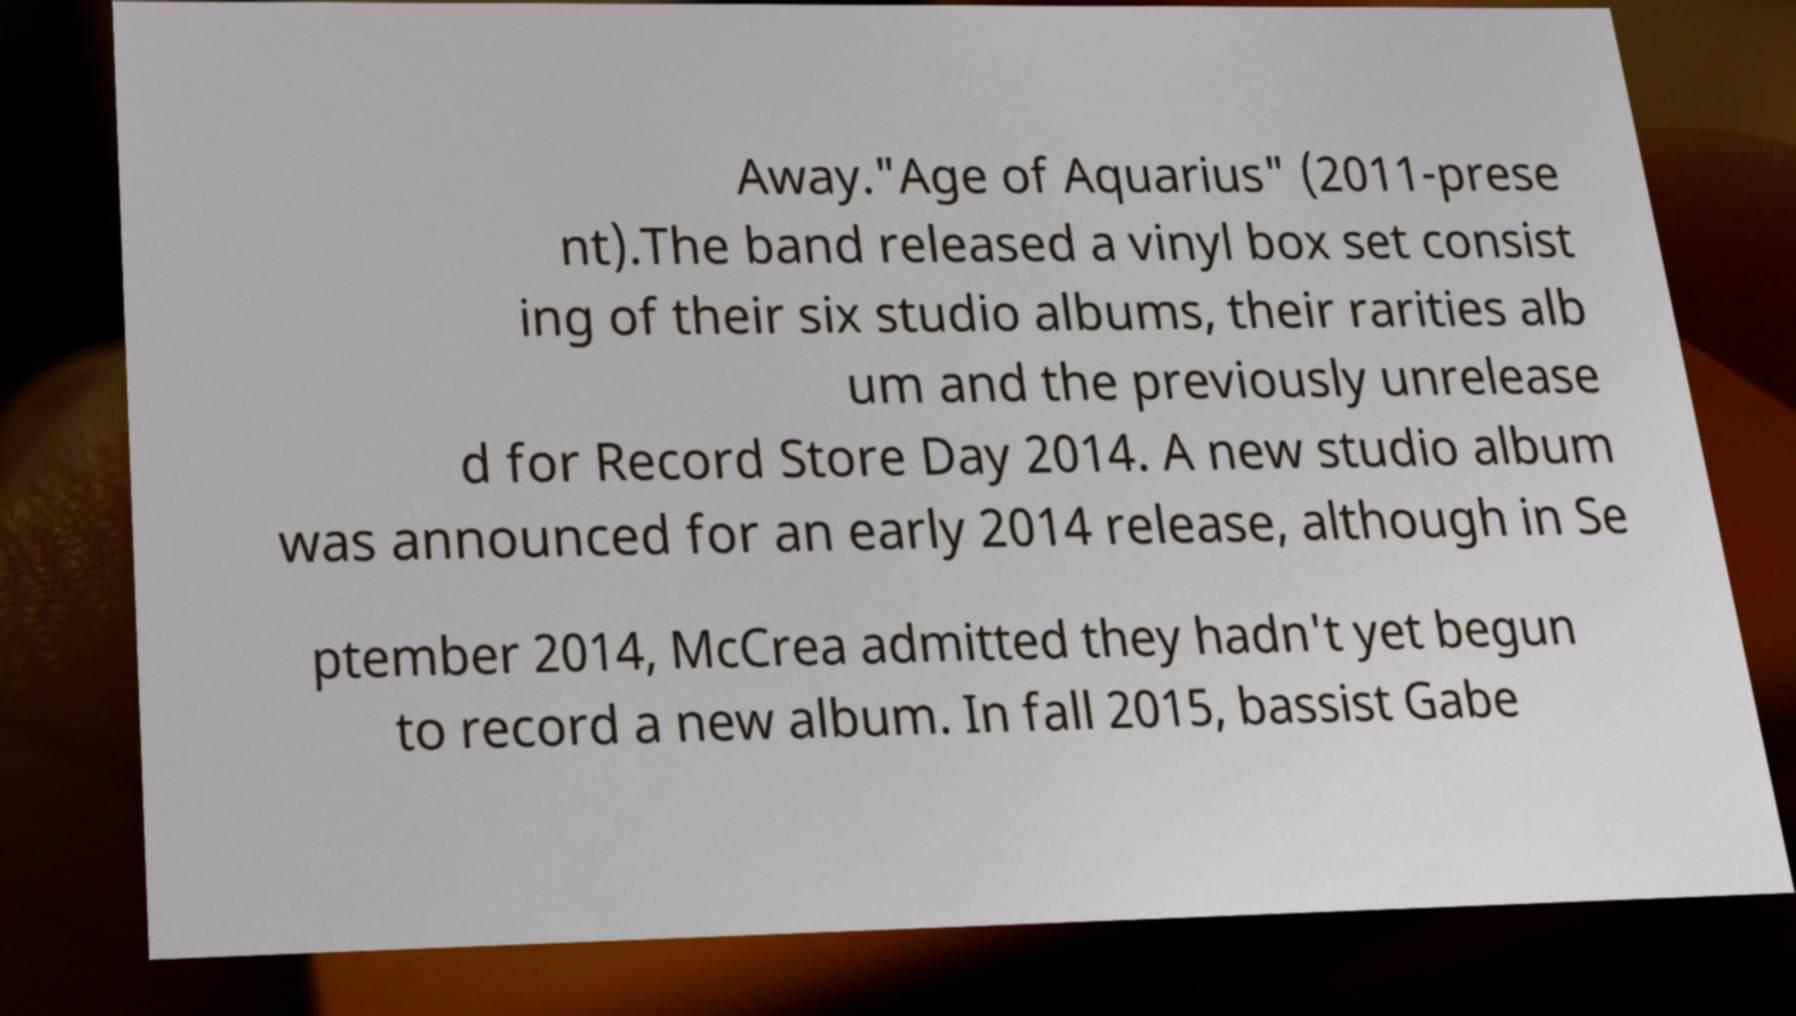For documentation purposes, I need the text within this image transcribed. Could you provide that? Away."Age of Aquarius" (2011-prese nt).The band released a vinyl box set consist ing of their six studio albums, their rarities alb um and the previously unrelease d for Record Store Day 2014. A new studio album was announced for an early 2014 release, although in Se ptember 2014, McCrea admitted they hadn't yet begun to record a new album. In fall 2015, bassist Gabe 